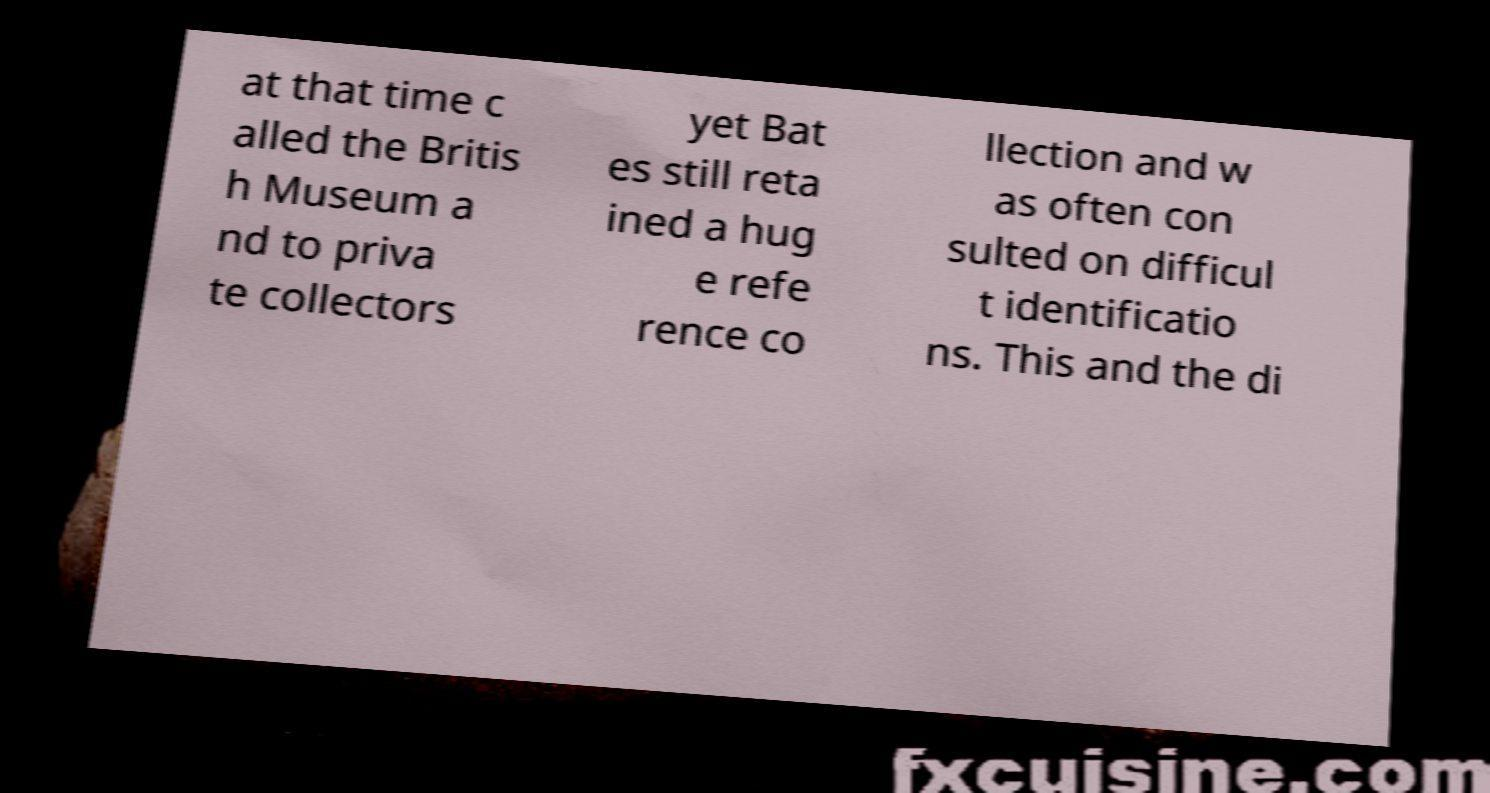There's text embedded in this image that I need extracted. Can you transcribe it verbatim? at that time c alled the Britis h Museum a nd to priva te collectors yet Bat es still reta ined a hug e refe rence co llection and w as often con sulted on difficul t identificatio ns. This and the di 